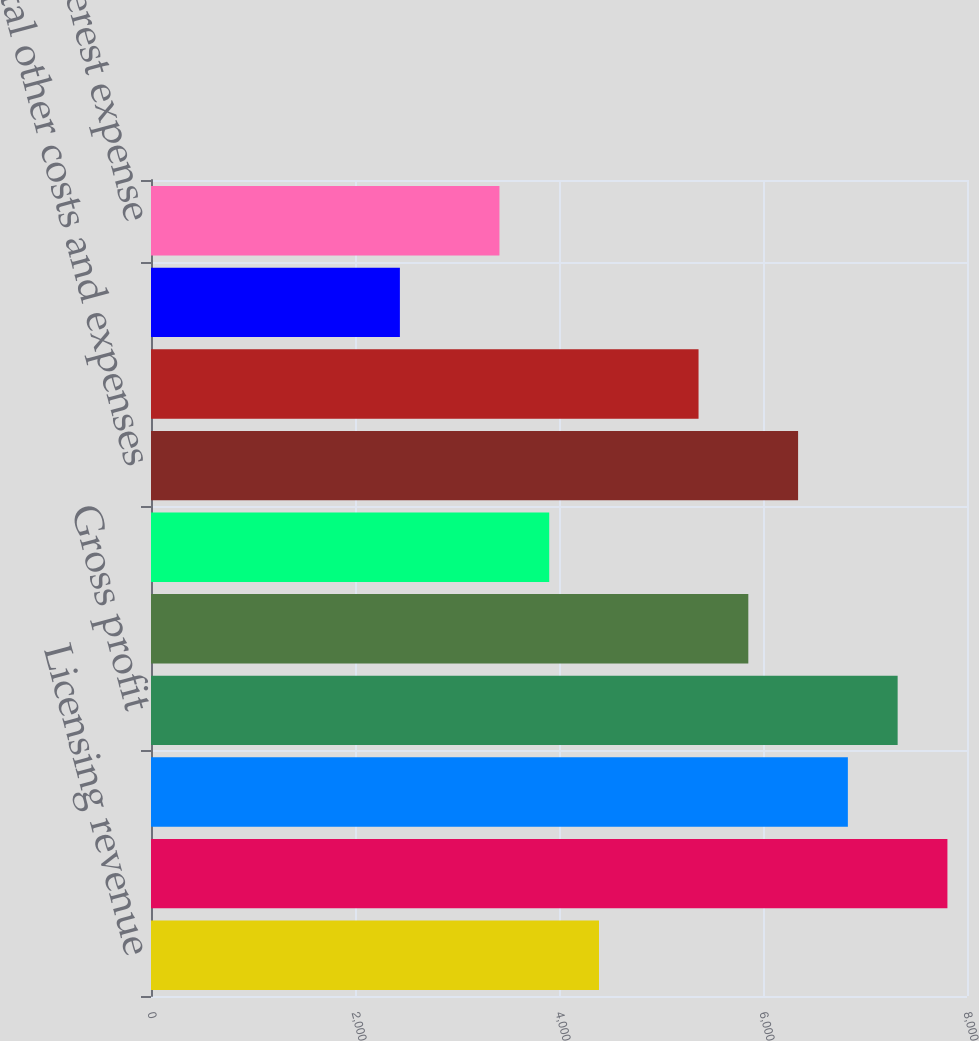Convert chart. <chart><loc_0><loc_0><loc_500><loc_500><bar_chart><fcel>Licensing revenue<fcel>Net revenues<fcel>Cost of goods sold (a)<fcel>Gross profit<fcel>Selling general and<fcel>Amortization of intangible<fcel>Total other costs and expenses<fcel>Operating income<fcel>Foreign currency gains<fcel>Interest expense<nl><fcel>4392.11<fcel>7808.04<fcel>6832.06<fcel>7320.05<fcel>5856.08<fcel>3904.12<fcel>6344.07<fcel>5368.09<fcel>2440.15<fcel>3416.13<nl></chart> 